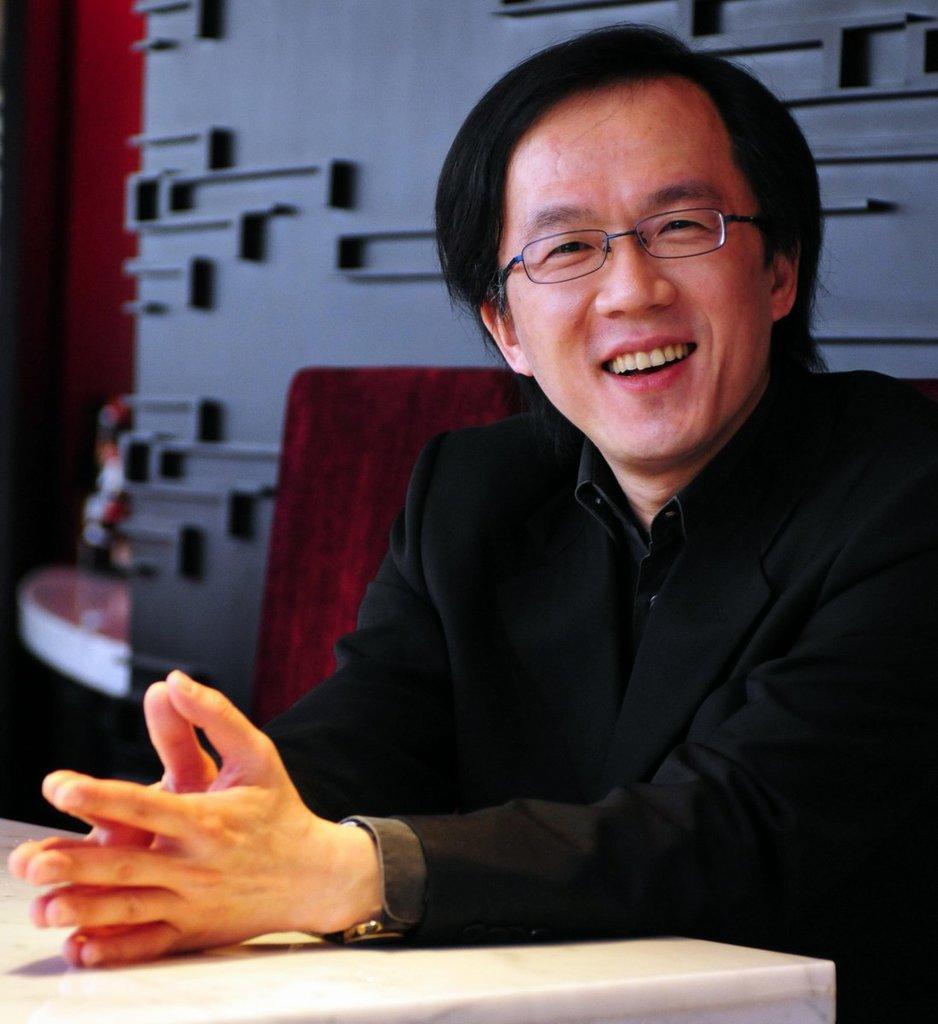Can you describe this image briefly? In this image, we can see a person wearing spectacles is sitting and is resting his hands on a white colored surface. In the background, we can see the decorated wall and some objects. We can also see some wood. 